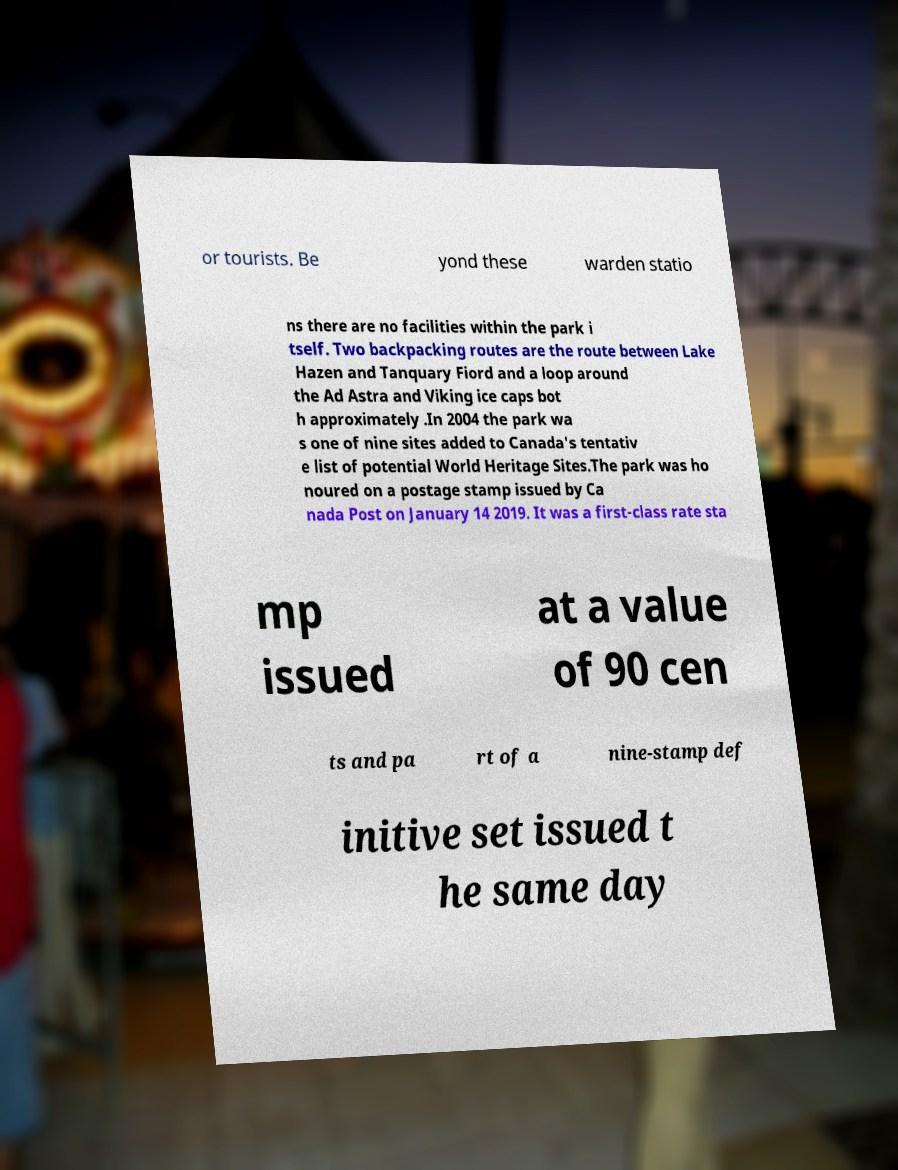Can you accurately transcribe the text from the provided image for me? or tourists. Be yond these warden statio ns there are no facilities within the park i tself. Two backpacking routes are the route between Lake Hazen and Tanquary Fiord and a loop around the Ad Astra and Viking ice caps bot h approximately .In 2004 the park wa s one of nine sites added to Canada's tentativ e list of potential World Heritage Sites.The park was ho noured on a postage stamp issued by Ca nada Post on January 14 2019. It was a first-class rate sta mp issued at a value of 90 cen ts and pa rt of a nine-stamp def initive set issued t he same day 